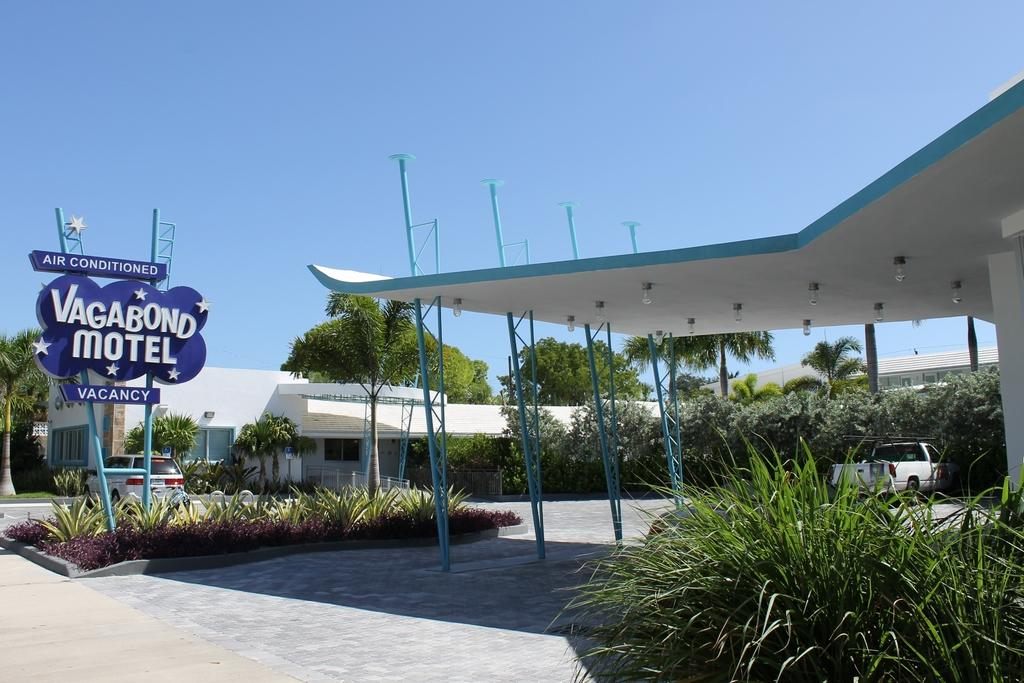<image>
Present a compact description of the photo's key features. a sign outside of a building that says 'air conditioned vagabond motel vacancy' 